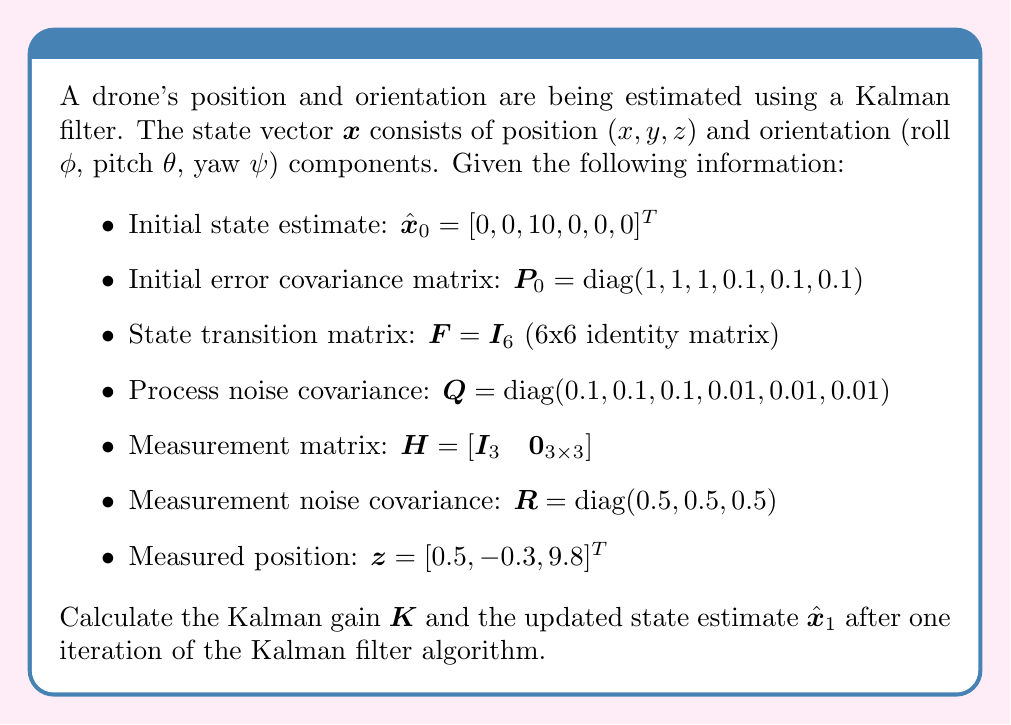Help me with this question. To solve this problem, we'll follow the Kalman filter algorithm step by step:

1. Predict step:
   a) State prediction: $\hat{\mathbf{x}}^-_1 = \mathbf{F}\hat{\mathbf{x}}_0$
   b) Error covariance prediction: $\mathbf{P}^-_1 = \mathbf{F}\mathbf{P}_0\mathbf{F}^T + \mathbf{Q}$

2. Update step:
   a) Calculate Kalman gain: $\mathbf{K} = \mathbf{P}^-_1\mathbf{H}^T(\mathbf{H}\mathbf{P}^-_1\mathbf{H}^T + \mathbf{R})^{-1}$
   b) Update state estimate: $\hat{\mathbf{x}}_1 = \hat{\mathbf{x}}^-_1 + \mathbf{K}(\mathbf{z} - \mathbf{H}\hat{\mathbf{x}}^-_1)$

Let's calculate each step:

1a. State prediction:
$$\hat{\mathbf{x}}^-_1 = \mathbf{I}_6 [0, 0, 10, 0, 0, 0]^T = [0, 0, 10, 0, 0, 0]^T$$

1b. Error covariance prediction:
$$\mathbf{P}^-_1 = \mathbf{I}_6 \text{diag}(1, 1, 1, 0.1, 0.1, 0.1) \mathbf{I}_6^T + \text{diag}(0.1, 0.1, 0.1, 0.01, 0.01, 0.01)$$
$$\mathbf{P}^-_1 = \text{diag}(1.1, 1.1, 1.1, 0.11, 0.11, 0.11)$$

2a. Kalman gain:
$$\mathbf{K} = \mathbf{P}^-_1\mathbf{H}^T(\mathbf{H}\mathbf{P}^-_1\mathbf{H}^T + \mathbf{R})^{-1}$$

First, calculate $\mathbf{H}\mathbf{P}^-_1\mathbf{H}^T$:
$$\mathbf{H}\mathbf{P}^-_1\mathbf{H}^T = [\mathbf{I}_3 \quad \mathbf{0}_{3\times3}] \text{diag}(1.1, 1.1, 1.1, 0.11, 0.11, 0.11) [\mathbf{I}_3 \quad \mathbf{0}_{3\times3}]^T$$
$$= \text{diag}(1.1, 1.1, 1.1)$$

Now, calculate $(\mathbf{H}\mathbf{P}^-_1\mathbf{H}^T + \mathbf{R})^{-1}$:
$$(\mathbf{H}\mathbf{P}^-_1\mathbf{H}^T + \mathbf{R})^{-1} = (\text{diag}(1.1, 1.1, 1.1) + \text{diag}(0.5, 0.5, 0.5))^{-1}$$
$$= \text{diag}(1.6, 1.6, 1.6)^{-1} = \text{diag}(0.625, 0.625, 0.625)$$

Finally, calculate $\mathbf{K}$:
$$\mathbf{K} = \text{diag}(1.1, 1.1, 1.1, 0.11, 0.11, 0.11) [\mathbf{I}_3 \quad \mathbf{0}_{3\times3}]^T \text{diag}(0.625, 0.625, 0.625)$$
$$\mathbf{K} = \begin{bmatrix}
0.6875 & 0 & 0 \\
0 & 0.6875 & 0 \\
0 & 0 & 0.6875 \\
0 & 0 & 0 \\
0 & 0 & 0 \\
0 & 0 & 0
\end{bmatrix}$$

2b. Update state estimate:
$$\hat{\mathbf{x}}_1 = \hat{\mathbf{x}}^-_1 + \mathbf{K}(\mathbf{z} - \mathbf{H}\hat{\mathbf{x}}^-_1)$$

First, calculate $\mathbf{z} - \mathbf{H}\hat{\mathbf{x}}^-_1$:
$$\mathbf{z} - \mathbf{H}\hat{\mathbf{x}}^-_1 = [0.5, -0.3, 9.8]^T - [\mathbf{I}_3 \quad \mathbf{0}_{3\times3}][0, 0, 10, 0, 0, 0]^T$$
$$= [0.5, -0.3, 9.8]^T - [0, 0, 10]^T = [0.5, -0.3, -0.2]^T$$

Now, calculate $\mathbf{K}(\mathbf{z} - \mathbf{H}\hat{\mathbf{x}}^-_1)$:
$$\mathbf{K}(\mathbf{z} - \mathbf{H}\hat{\mathbf{x}}^-_1) = \begin{bmatrix}
0.6875 & 0 & 0 \\
0 & 0.6875 & 0 \\
0 & 0 & 0.6875 \\
0 & 0 & 0 \\
0 & 0 & 0 \\
0 & 0 & 0
\end{bmatrix} [0.5, -0.3, -0.2]^T = [0.34375, -0.20625, -0.1375, 0, 0, 0]^T$$

Finally, calculate $\hat{\mathbf{x}}_1$:
$$\hat{\mathbf{x}}_1 = [0, 0, 10, 0, 0, 0]^T + [0.34375, -0.20625, -0.1375, 0, 0, 0]^T$$
$$\hat{\mathbf{x}}_1 = [0.34375, -0.20625, 9.8625, 0, 0, 0]^T$$
Answer: $\mathbf{K} = \begin{bmatrix}
0.6875 & 0 & 0 \\
0 & 0.6875 & 0 \\
0 & 0 & 0.6875 \\
0 & 0 & 0 \\
0 & 0 & 0 \\
0 & 0 & 0
\end{bmatrix}$, $\hat{\mathbf{x}}_1 = [0.34375, -0.20625, 9.8625, 0, 0, 0]^T$ 